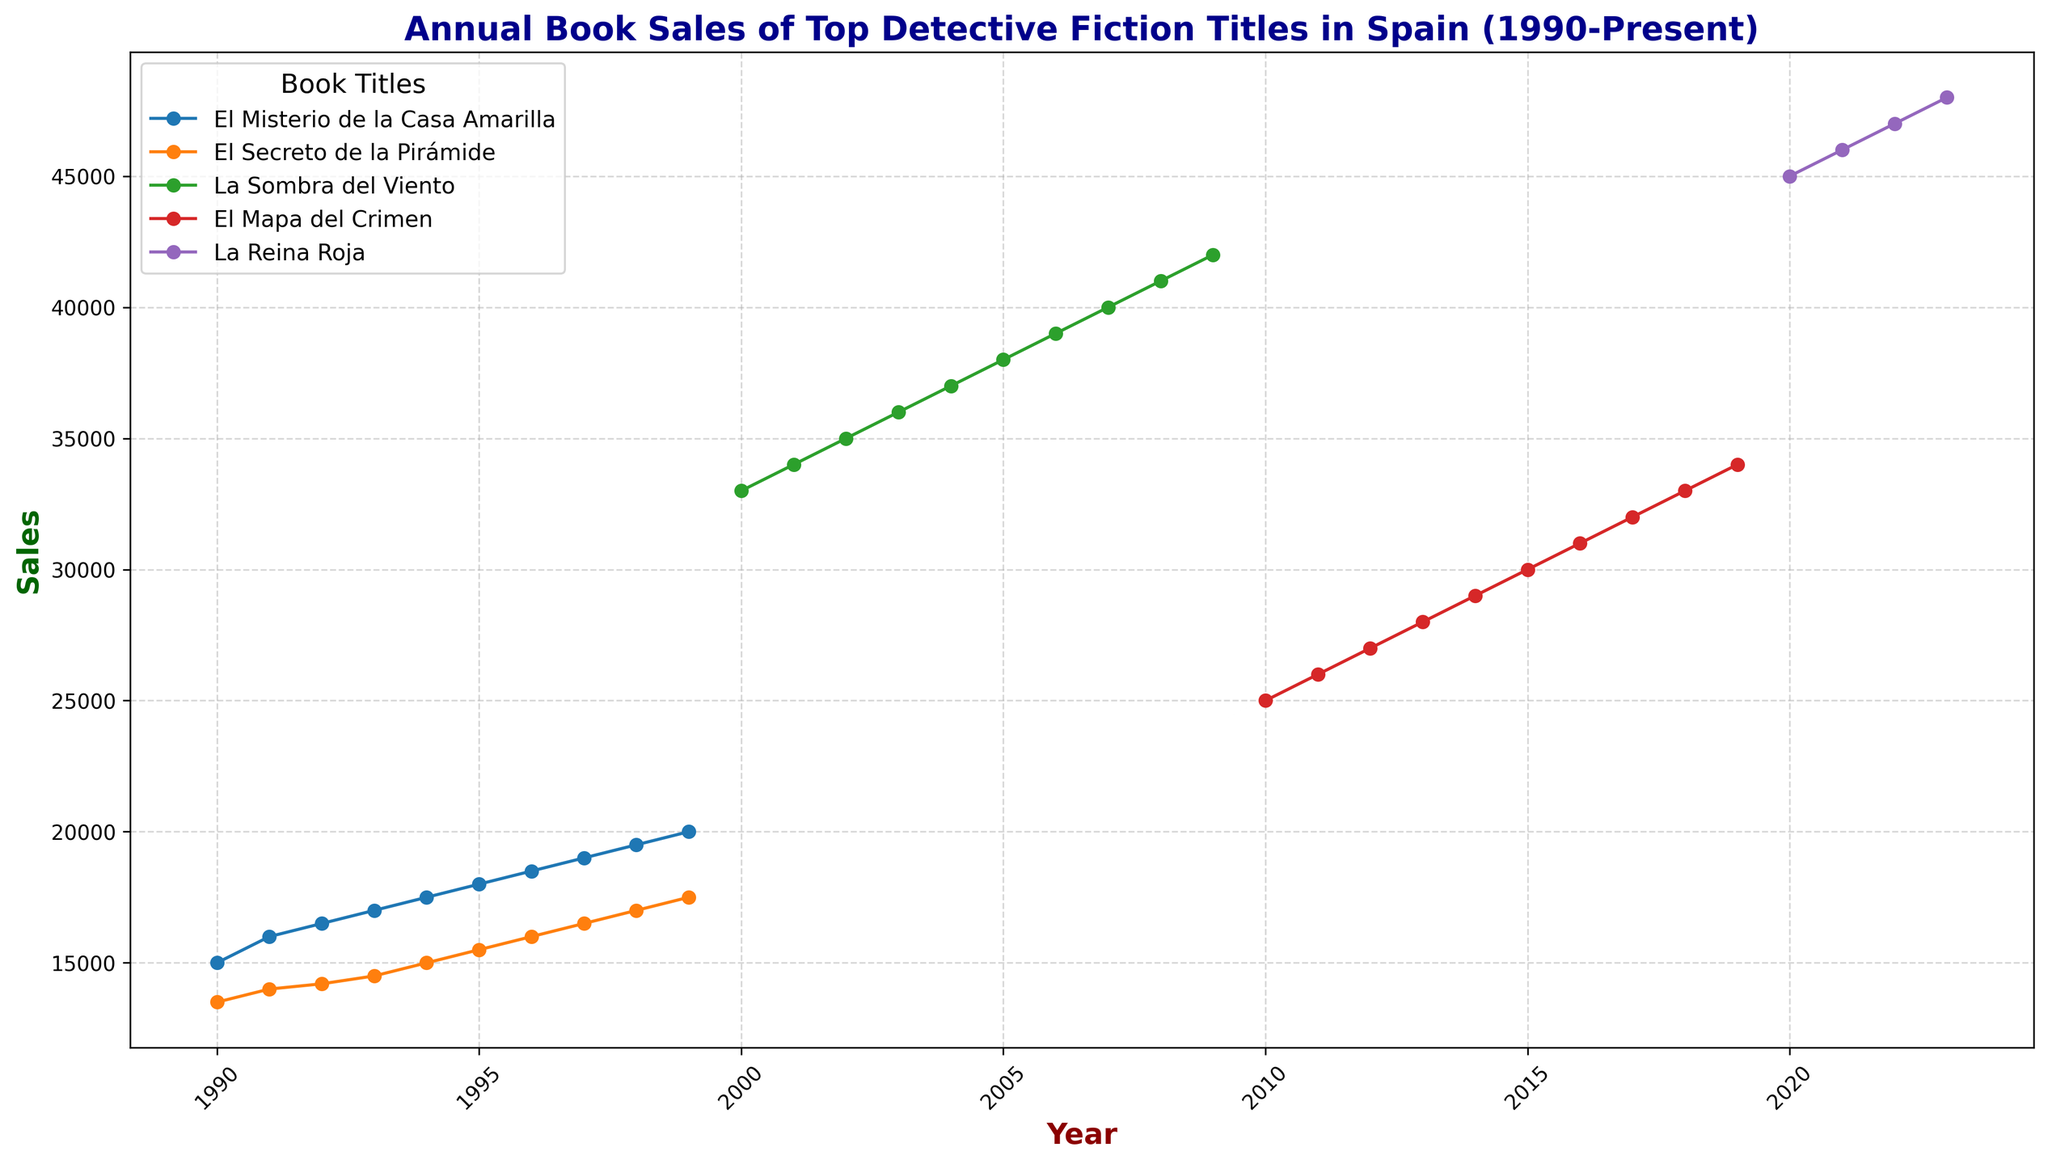What trend is observed for "La Sombra del Viento" sales from 2000 to 2009? The sales of "La Sombra del Viento" consistently increase each year from 2000 to 2009, rising from 33,000 in 2000 to 42,000 in 2009.
Answer: Consistent increase Which book showed the highest sales in 2023? Looking at the plotted lines for 2023, "La Reina Roja" reached 48,000 sales, the highest among all titles in that year.
Answer: La Reina Roja By how much did the sales of "El Misterio de la Casa Amarilla" increase from 1990 to 1999? In 1990, the sales were 15,000 and in 1999, they were 20,000. The increase is 20,000 - 15,000 = 5,000.
Answer: 5,000 Which book has the flattest growth curve over its entire period? From visual inspection, "El Mapa del Crimen" shows a relatively steady and linear growth, without sharp rises or falls from 2010 to 2019.
Answer: El Mapa del Crimen How do the sales of "El Secreto de la Pirámide" in 1997 compare to those of "El Misterio de la Casa Amarilla" in the same year? In 1997, "El Secreto de la Pirámide" had sales of 16,500, while "El Misterio de la Casa Amarilla" had 19,000. "El Misterio de la Casa Amarilla" sold more.
Answer: El Misterio de la Casa Amarilla sold more Which title experienced the largest single-year increase in sales and in what year? "La Sombra del Viento" increased from 33,000 in 2000 to 34,000 in 2001, a 1,000 increase. This steady increase pattern is consistent until 2009 where it reached 42,000. However, "La Reina Roja" had an increase of 1,000 each year from 2020 to 2023 starting from a higher base.
Answer: La Reina Roja, 2020 What visual pattern is evident for the book with the highest peak in sales? "La Reina Roja" has the highest peak sales which creates a steep upward sloping line ending at 48,000 in 2023, visually represented by a bright and prominent color.
Answer: Steep upward sloping line 